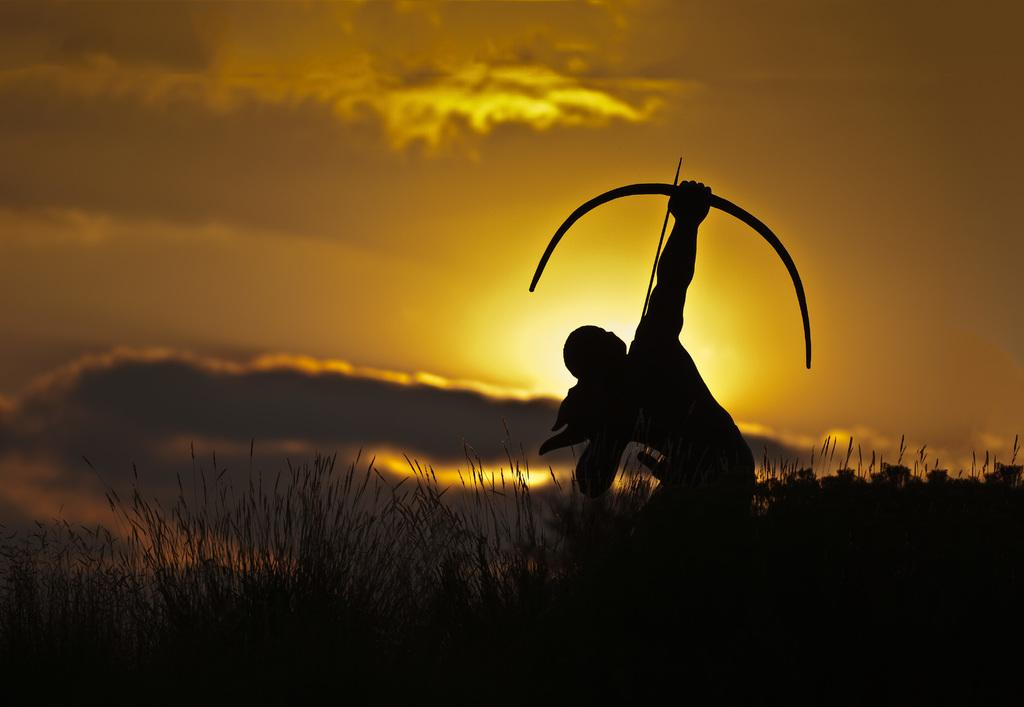Who is present in the image? There is a person in the image. What is the person holding in the image? The person is holding a bow and arrow. Where is the person standing in the image? The person is standing in the grass. What can be seen in the sky in the image? There are clouds in the sky. What time of day is depicted in the image? The sunrise is visible in the image, indicating that it is early morning. What type of polish is the goose applying to its feathers in the image? There is no goose present in the image, and therefore no polish or feathers can be observed. 